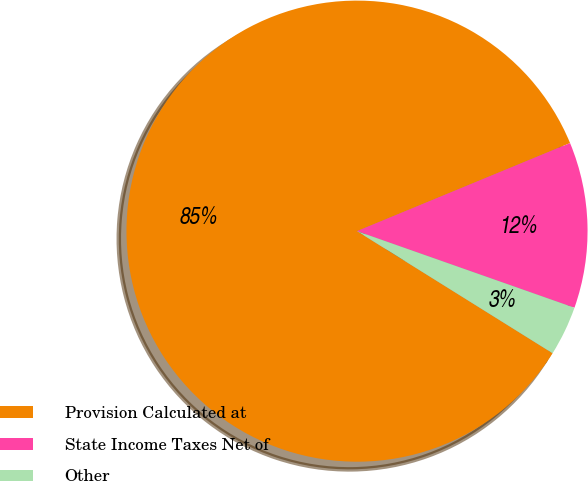Convert chart. <chart><loc_0><loc_0><loc_500><loc_500><pie_chart><fcel>Provision Calculated at<fcel>State Income Taxes Net of<fcel>Other<nl><fcel>84.88%<fcel>11.63%<fcel>3.49%<nl></chart> 